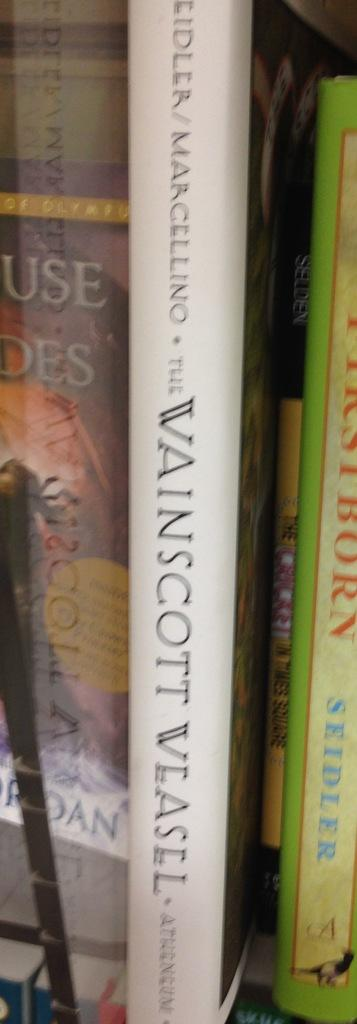<image>
Relay a brief, clear account of the picture shown. The book Vainscott Vlasel sits on a bookself. 